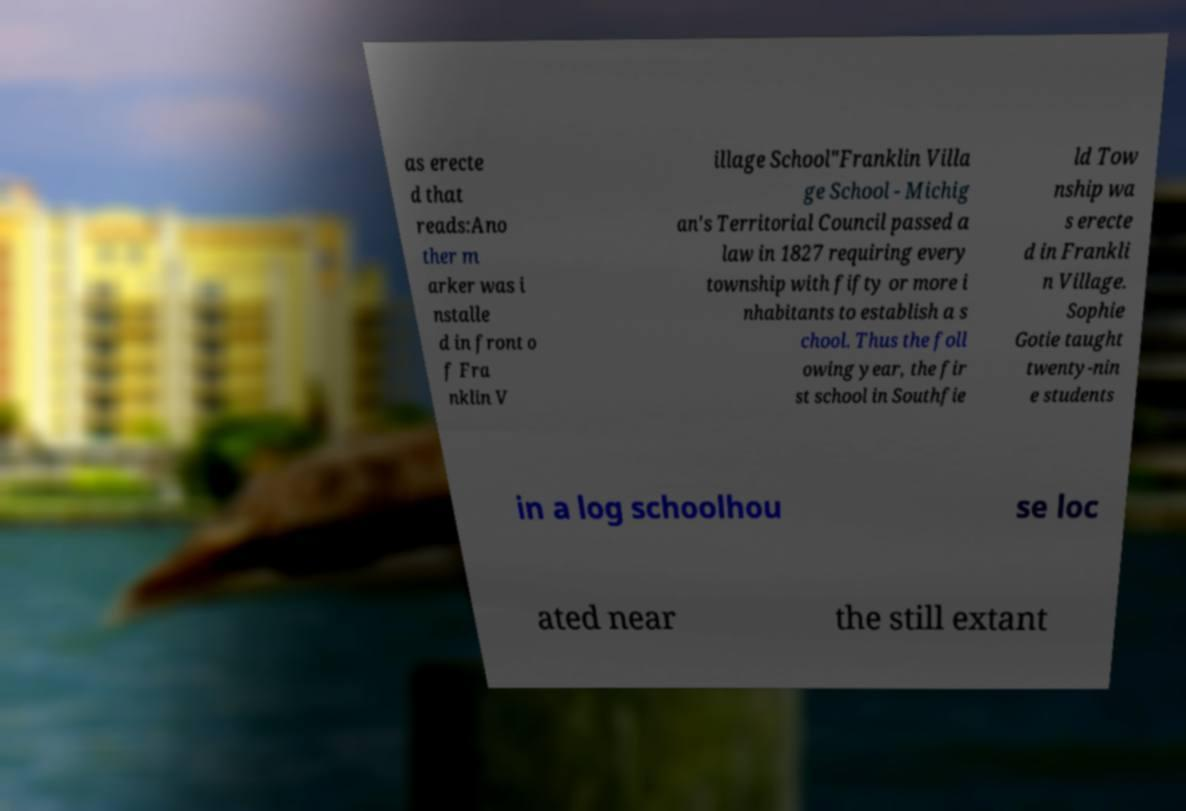Can you read and provide the text displayed in the image?This photo seems to have some interesting text. Can you extract and type it out for me? as erecte d that reads:Ano ther m arker was i nstalle d in front o f Fra nklin V illage School"Franklin Villa ge School - Michig an's Territorial Council passed a law in 1827 requiring every township with fifty or more i nhabitants to establish a s chool. Thus the foll owing year, the fir st school in Southfie ld Tow nship wa s erecte d in Frankli n Village. Sophie Gotie taught twenty-nin e students in a log schoolhou se loc ated near the still extant 